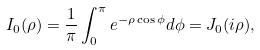Convert formula to latex. <formula><loc_0><loc_0><loc_500><loc_500>I _ { 0 } ( \rho ) = \frac { 1 } { \pi } \int _ { 0 } ^ { \pi } e ^ { - \rho \cos \phi } d \phi = J _ { 0 } ( i \rho ) ,</formula> 